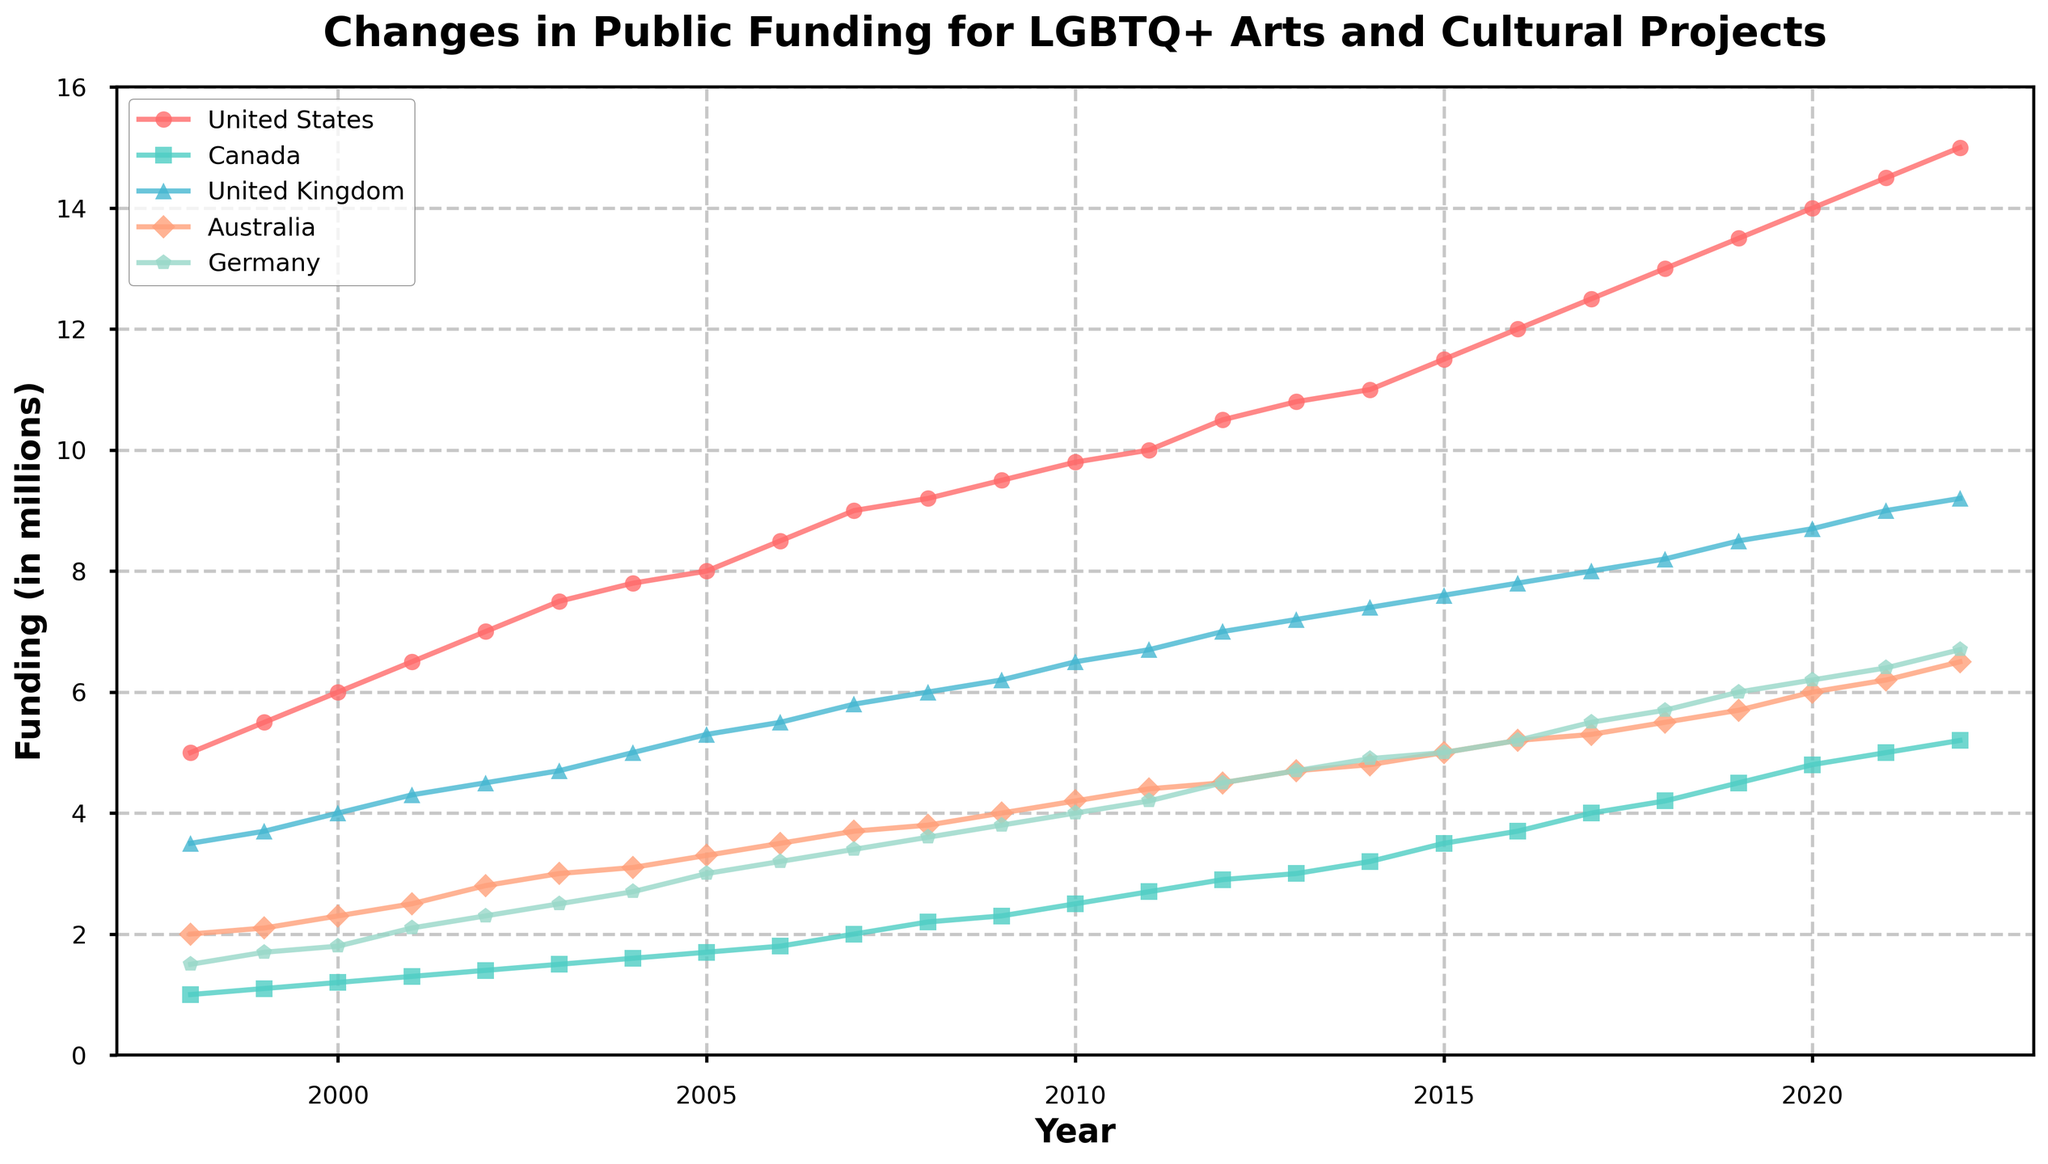What is the title of the figure? The title is written at the top of the figure. Reading it carefully gives the answer.
Answer: Changes in Public Funding for LGBTQ+ Arts and Cultural Projects Which country had the highest public funding in 2022? Look at the 2022 data points and compare the values of all countries. The highest value indicates the country with the highest funding.
Answer: United States How much did public funding in Germany increase from 1998 to 2022? Subtract the 1998 funding for Germany from the 2022 funding for Germany: 6.7 - 1.5.
Answer: 5.2 million Which two countries experienced the most consistent increase in funding over the 25 years? Identify the countries whose lines show a steady upward trend without large fluctuations over the 25-year period.
Answer: United States and United Kingdom During which period did Canada see the largest increase in public funding? Look at the slopes of the line representing Canada and identify the steepest section, indicating the largest increase over that period.
Answer: 2017 to 2019 How does the trend of the United States compare to the trend of Australia? Observe the slopes and general direction of the lines for both countries. Notice their rate of increase and consistency over the years.
Answer: The United States shows a more consistent and steeper increase compared to Australia What was the funding amount for the United Kingdom in 2010, and how does it compare to Canada's funding in the same year? Point out the data for both countries in 2010 and compare the values: United Kingdom's funding in 2010 vs. Canada's funding in 2010.
Answer: United Kingdom had 6.5 million, and Canada had 2.5 million What is the overall trend for public funding in Germany over the last 25 years? Analyze the line representing Germany over the entire timeline, noting the general direction.
Answer: An increasing trend Between 2005 and 2010, which country had the smallest increase in funding? Calculate the change in funding for each country from 2005 to 2010 and identify the smallest change among them.
Answer: Canada What is the average public funding for LGBTQ+ arts and cultural projects in Australia over the last 25 years? Sum up all the annual values for Australia and then divide by the number of years (25) to find the average.
Answer: (2.0+2.1+2.3+2.5+2.8+3.0+3.1+3.3+3.5+3.7+3.8+4.0+4.2+4.4+4.5+4.7+4.8+5.0+5.2+5.3+5.5+5.7+6.0+6.2+6.5) / 25 = 4.12 million 